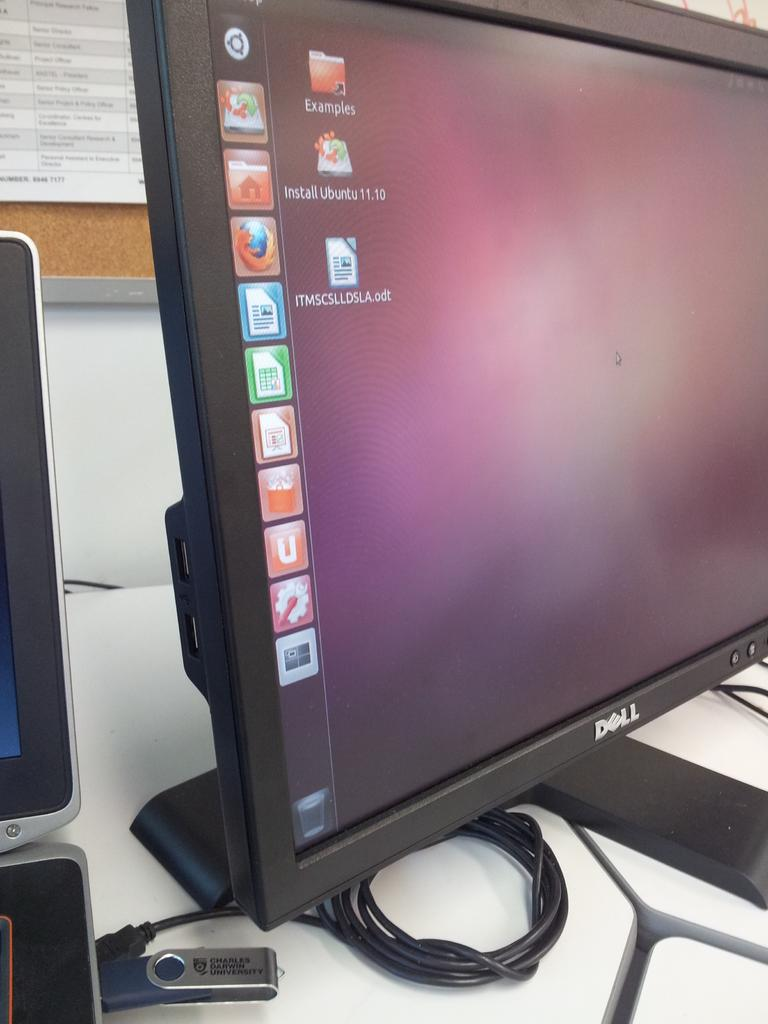<image>
Summarize the visual content of the image. A folder filled with examples is at the top of the computer screen. 